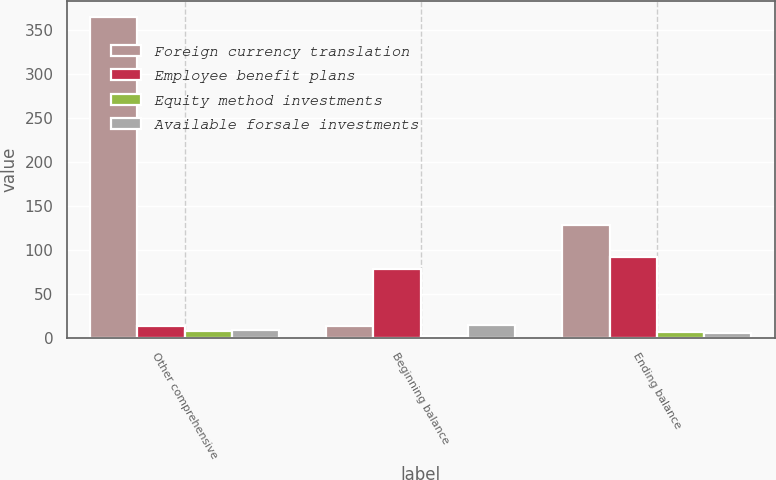<chart> <loc_0><loc_0><loc_500><loc_500><stacked_bar_chart><ecel><fcel>Other comprehensive<fcel>Beginning balance<fcel>Ending balance<nl><fcel>Foreign currency translation<fcel>364.4<fcel>13.8<fcel>128.1<nl><fcel>Employee benefit plans<fcel>13.8<fcel>77.9<fcel>91.7<nl><fcel>Equity method investments<fcel>8.3<fcel>1.8<fcel>6.5<nl><fcel>Available forsale investments<fcel>9.2<fcel>15.1<fcel>5.9<nl></chart> 